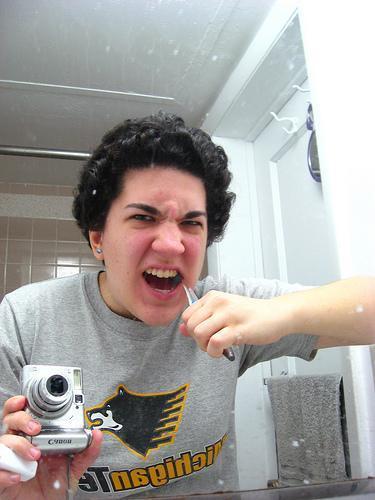How many hooks?
Give a very brief answer. 2. How many people are in the picture?
Give a very brief answer. 1. 